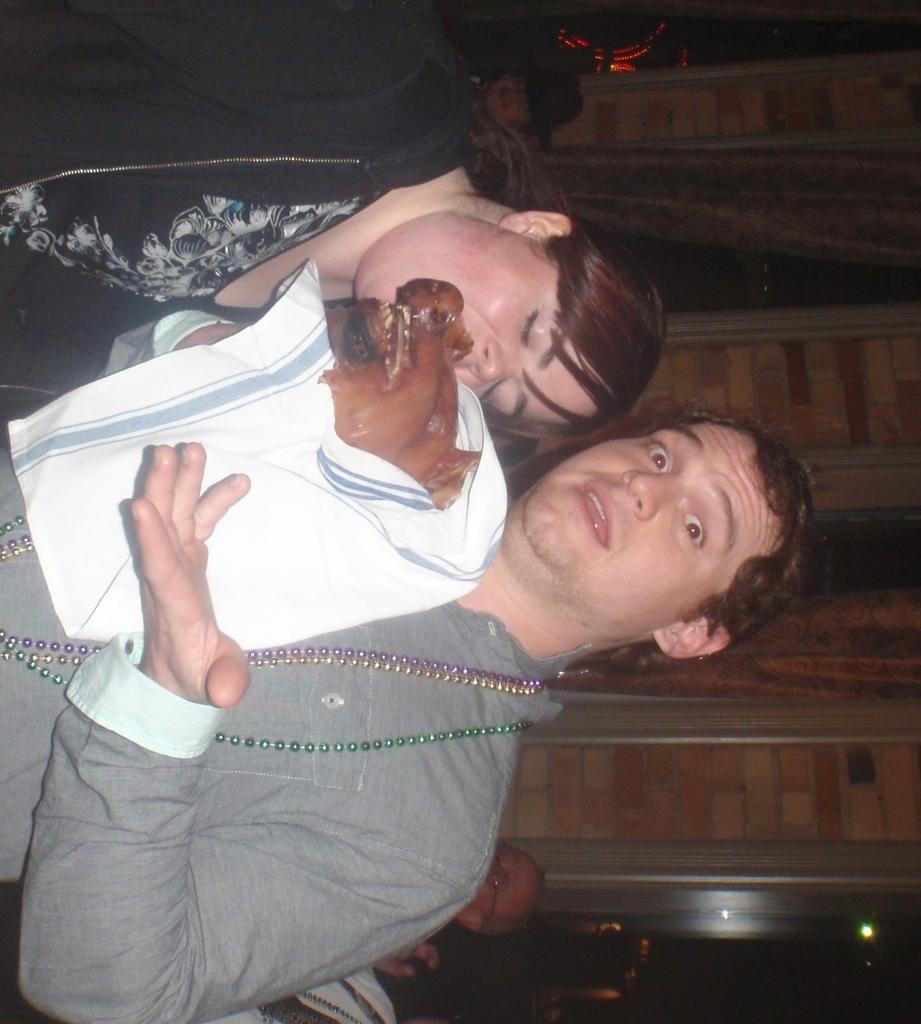Could you give a brief overview of what you see in this image? There is a man and a woman. Man is wearing chains and holding something in a white cloth. In the back there are few people and brick wall. 